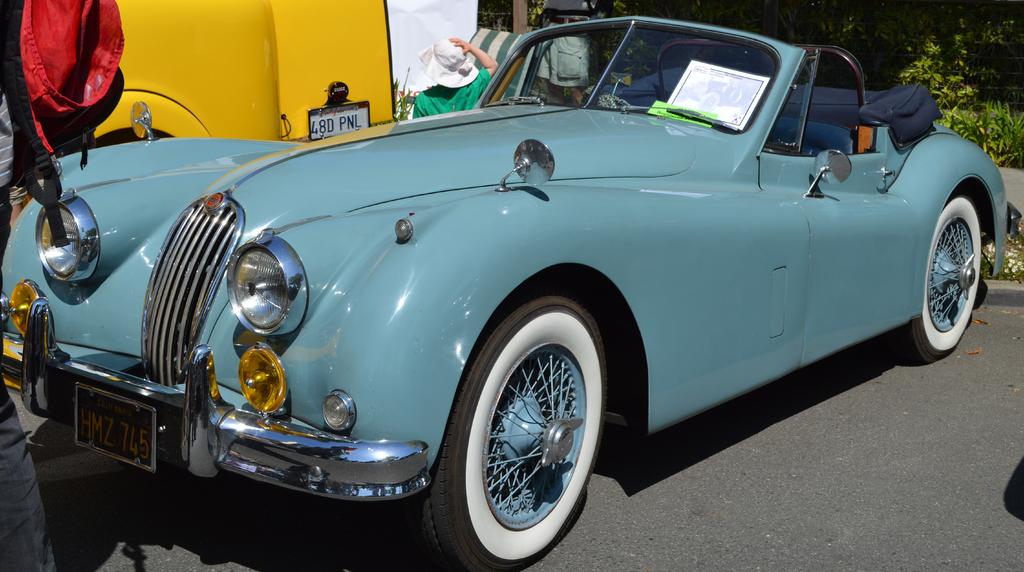What is the main subject of the image? There is a car in the center of the image. Can you describe the car? The car is blue. What can be seen in the background of the image? There are trees, bags, at least one other vehicle, and a person standing in the background of the image. Are there any other objects visible in the background? Yes, there are a few other objects in the background of the image. What type of government is depicted in the image? There is no depiction of a government in the image; it features a blue car and various background elements. What action is the dirt performing in the image? There is no dirt present in the image, so it cannot perform any actions. 